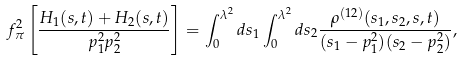<formula> <loc_0><loc_0><loc_500><loc_500>f _ { \pi } ^ { 2 } \left [ { \frac { H _ { 1 } ( s , t ) + H _ { 2 } ( s , t ) } { p _ { 1 } ^ { 2 } p _ { 2 } ^ { 2 } } } \right ] = \int _ { 0 } ^ { \lambda ^ { 2 } } d s _ { 1 } \int _ { 0 } ^ { \lambda ^ { 2 } } d s _ { 2 } { \frac { \rho ^ { ( 1 2 ) } ( s _ { 1 } , s _ { 2 } , s , t ) } { ( s _ { 1 } - p _ { 1 } ^ { 2 } ) ( s _ { 2 } - p _ { 2 } ^ { 2 } ) } } ,</formula> 